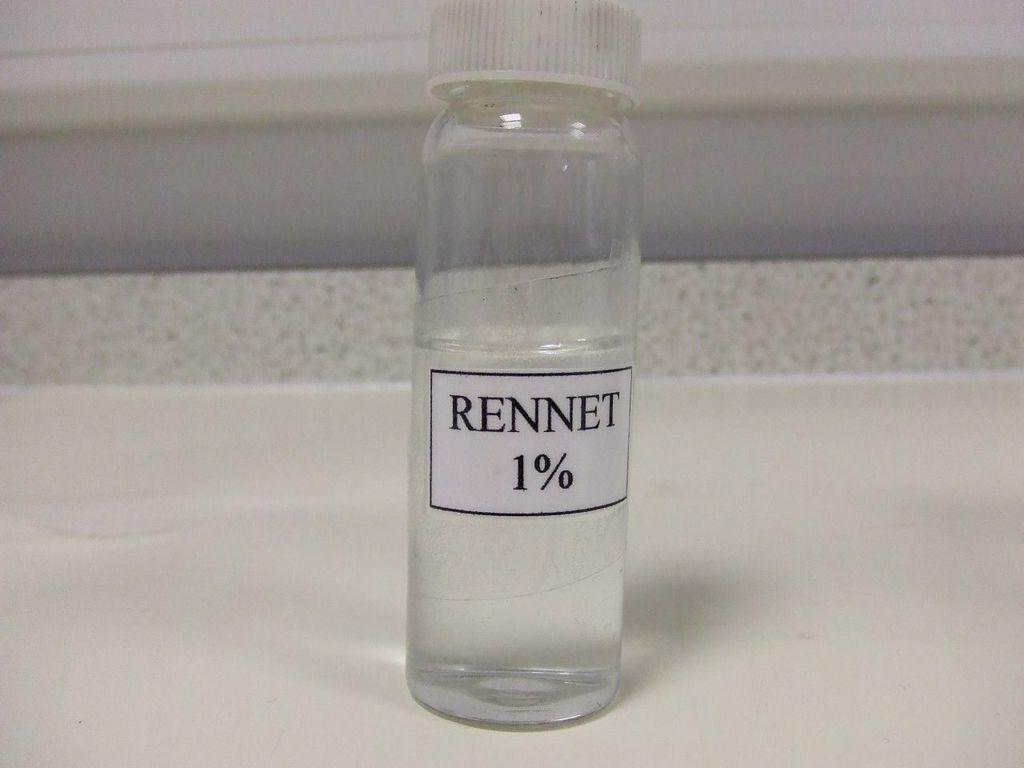Provide a one-sentence caption for the provided image. a bottle with the word Rennet on it. 